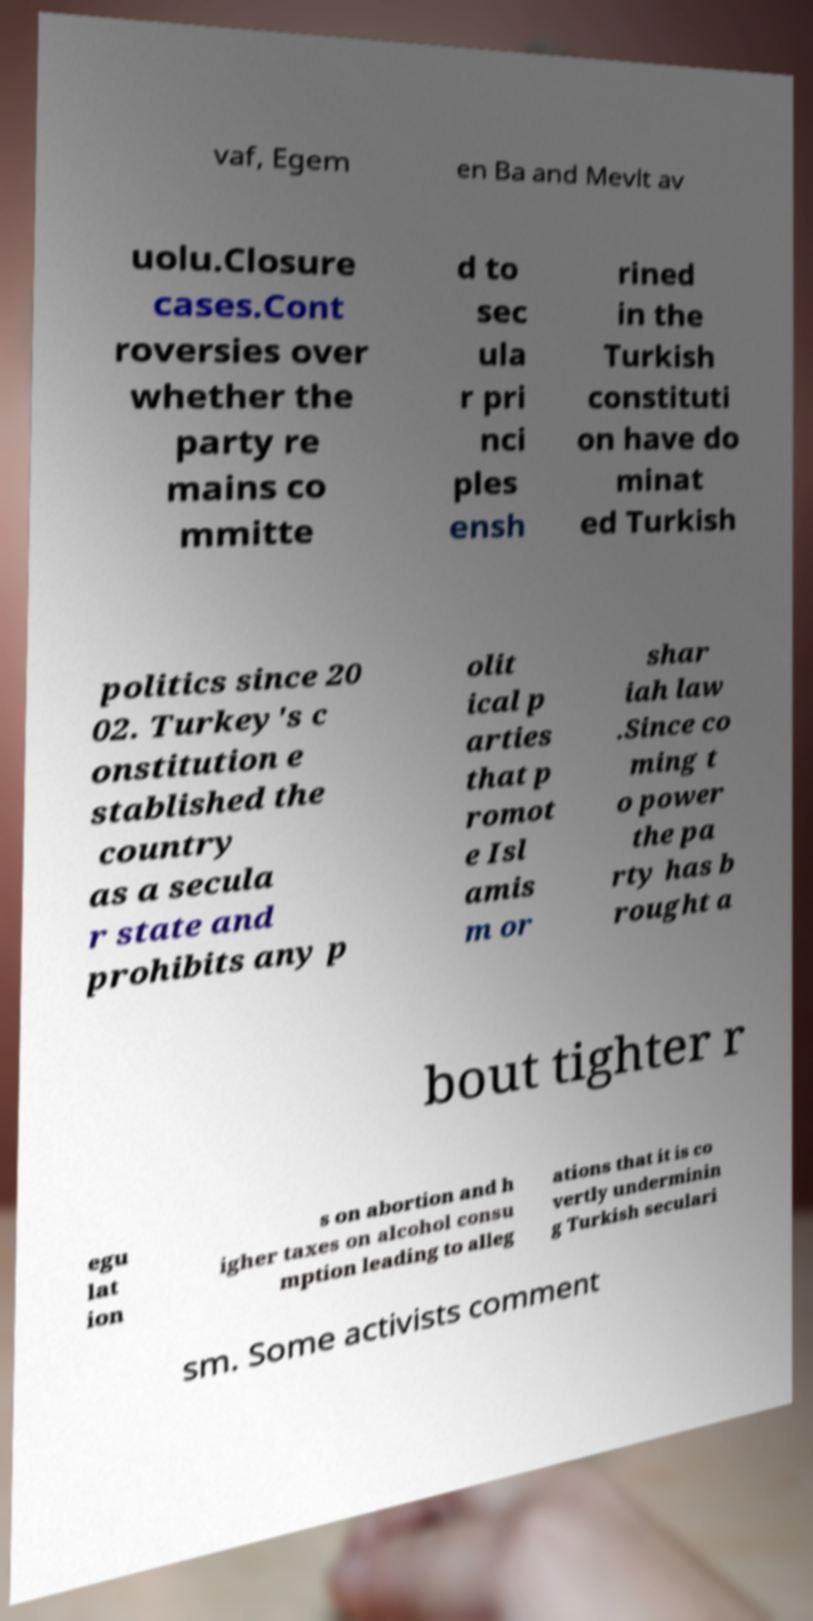Could you assist in decoding the text presented in this image and type it out clearly? vaf, Egem en Ba and Mevlt av uolu.Closure cases.Cont roversies over whether the party re mains co mmitte d to sec ula r pri nci ples ensh rined in the Turkish constituti on have do minat ed Turkish politics since 20 02. Turkey's c onstitution e stablished the country as a secula r state and prohibits any p olit ical p arties that p romot e Isl amis m or shar iah law .Since co ming t o power the pa rty has b rought a bout tighter r egu lat ion s on abortion and h igher taxes on alcohol consu mption leading to alleg ations that it is co vertly underminin g Turkish seculari sm. Some activists comment 